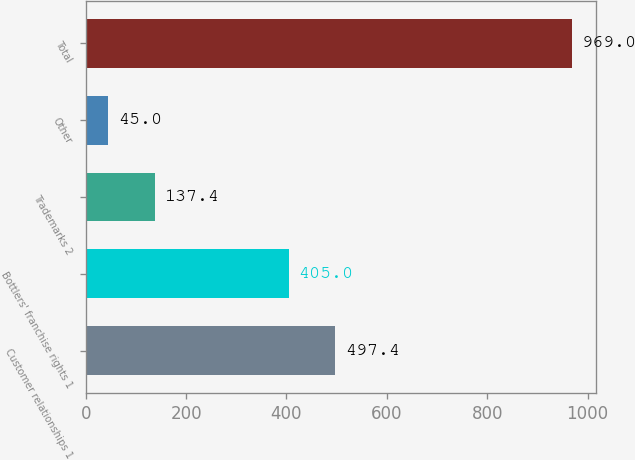Convert chart to OTSL. <chart><loc_0><loc_0><loc_500><loc_500><bar_chart><fcel>Customer relationships 1<fcel>Bottlers' franchise rights 1<fcel>Trademarks 2<fcel>Other<fcel>Total<nl><fcel>497.4<fcel>405<fcel>137.4<fcel>45<fcel>969<nl></chart> 